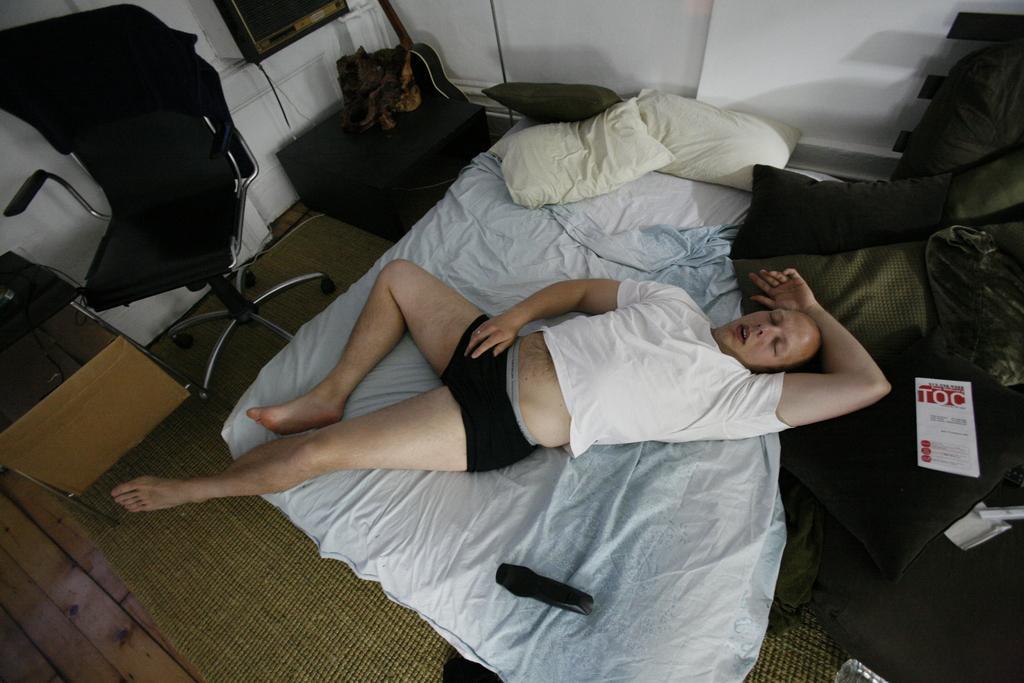Can you describe this image briefly? In this image i can see a person sleeping on the bed and few pillows. In the background i can see a wall, a chair and a television. 